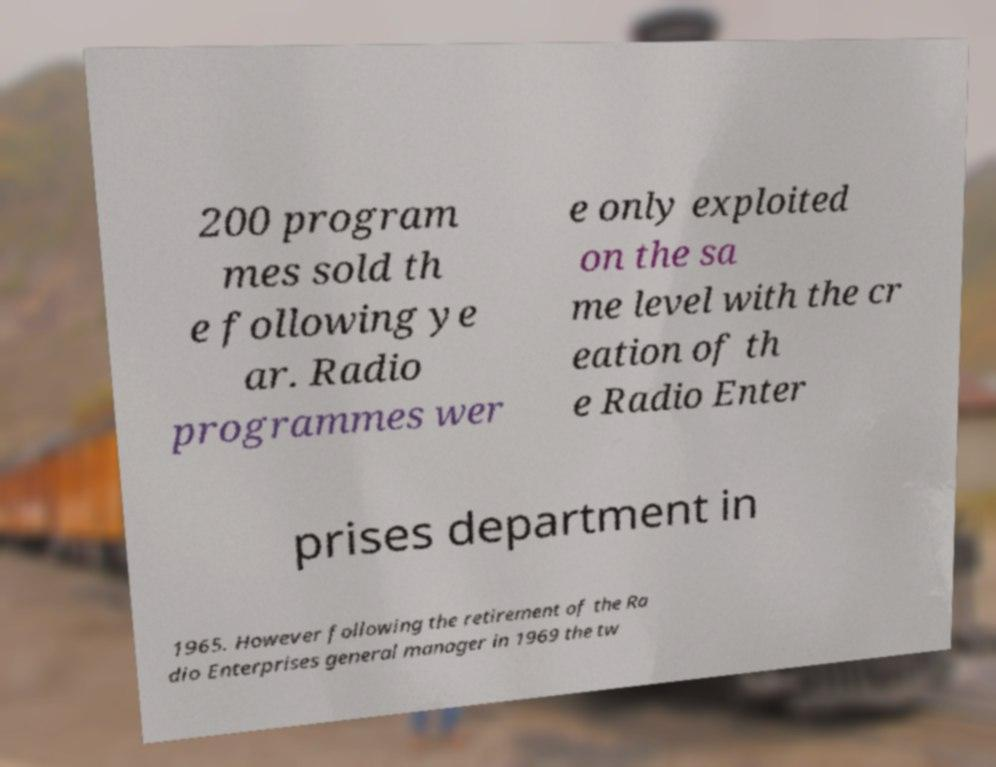Please read and relay the text visible in this image. What does it say? 200 program mes sold th e following ye ar. Radio programmes wer e only exploited on the sa me level with the cr eation of th e Radio Enter prises department in 1965. However following the retirement of the Ra dio Enterprises general manager in 1969 the tw 